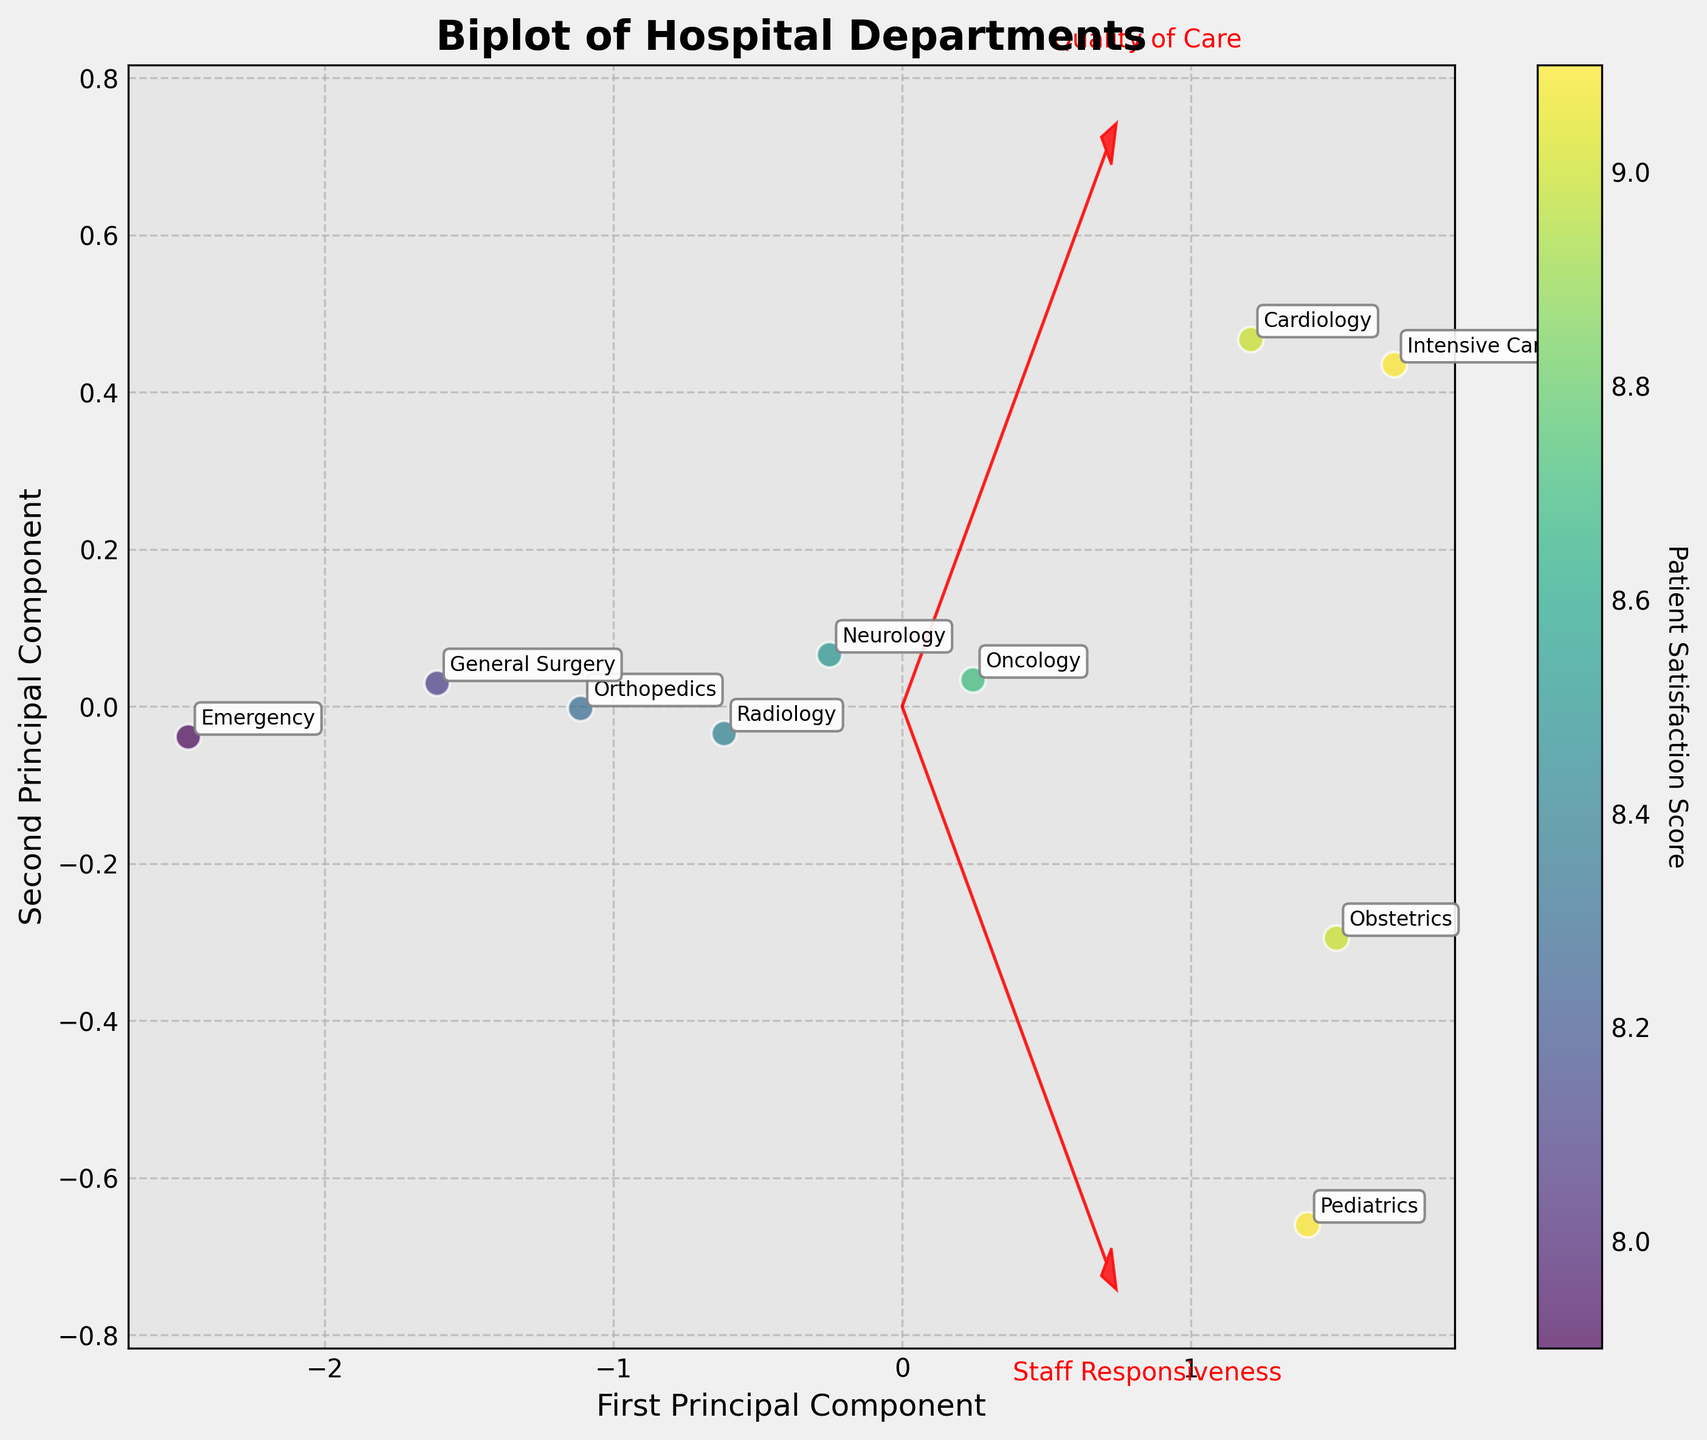Which department has the highest Patient Satisfaction Score? By examining the scattered data points colored based on the Patient Satisfaction Score, we identify that the Pediatrics and Intensive Care Departments have the highest score, both recording a satisfaction score of 9.1
Answer: Pediatrics and Intensive Care What are the labels of the axes in this plot? The labels on the x-axis and y-axis of the plot are named "First Principal Component" and "Second Principal Component" derived from the PCA transformation of the data
Answer: First Principal Component, Second Principal Component Which department scores highest on the quality of care and where is it plotted? By looking at the vector direction representing "Quality of Care", Orthopedics department is plotted farthest in that direction. Cross-referencing, the Intensive Care department scores the highest with a value of 9.2
Answer: Intensive Care What's the average Patient Satisfaction Score across all departments? Summing the Patient Satisfaction Scores: 7.9+9.0+9.1+8.7+8.3+8.5+9.0+8.1+9.1+8.4 = 86.1. Dividing by the number of departments: 86.1/10 = 8.61
Answer: 8.61 Which department has similar performance in terms of quality of care and staff responsiveness? From the relative positioning of vectors and the data points, Obstetrics Department scores nearly equally on Quality of Care and Staff Responsiveness both around 9.0 and 9.1
Answer: Obstetrics What trend does the plot suggest about the relationship between Quality of Care and Patient Satisfaction Score? The plot suggests a positive correlation, as departments plotted in the direction of higher Quality of Care tend to have higher Patient Satisfaction Scores, indicated by more vibrant colors
Answer: Positive Correlation Which department has the lowest Staff Responsiveness and where is it in the plot? The Emergency Department has the lowest Staff Responsiveness with a score of 7.5. It is plotted closest to the origin towards the left (lower scores) in the biplot
Answer: Emergency Where is Cardiology Department plotted and how does it compare to Pediatrics in terms of Staff Responsiveness? Cardiology is plotted closely right of the center of the biplot with high values on both PCA axes. Comparing to Pediatrics on Staff Responsiveness, Cardiology (8.7) is slightly lower than Pediatrics (9.2)
Answer: To the right of center; slightly lower Staff Responsiveness Based on vector positioning, which component (Quality of Care or Staff Responsiveness) influences Patient Satisfaction Scores more significantly? Evaluating the length of vectors, both seem influential, but the Quality of Care vector (x-direction) has slightly longer projection in some departments hinting it might influence more significantly
Answer: Slightly more significant: Quality of Care Which departments are closest to each other on the biplot and why? Oncology and Neurology departments are plotted close to each other, indicating that they have similar scores in both Quality of Care and Staff Responsiveness as well as a close Patient Satisfaction Score (Oncology 8.7, Neurology 8.5)
Answer: Oncology and Neurology 